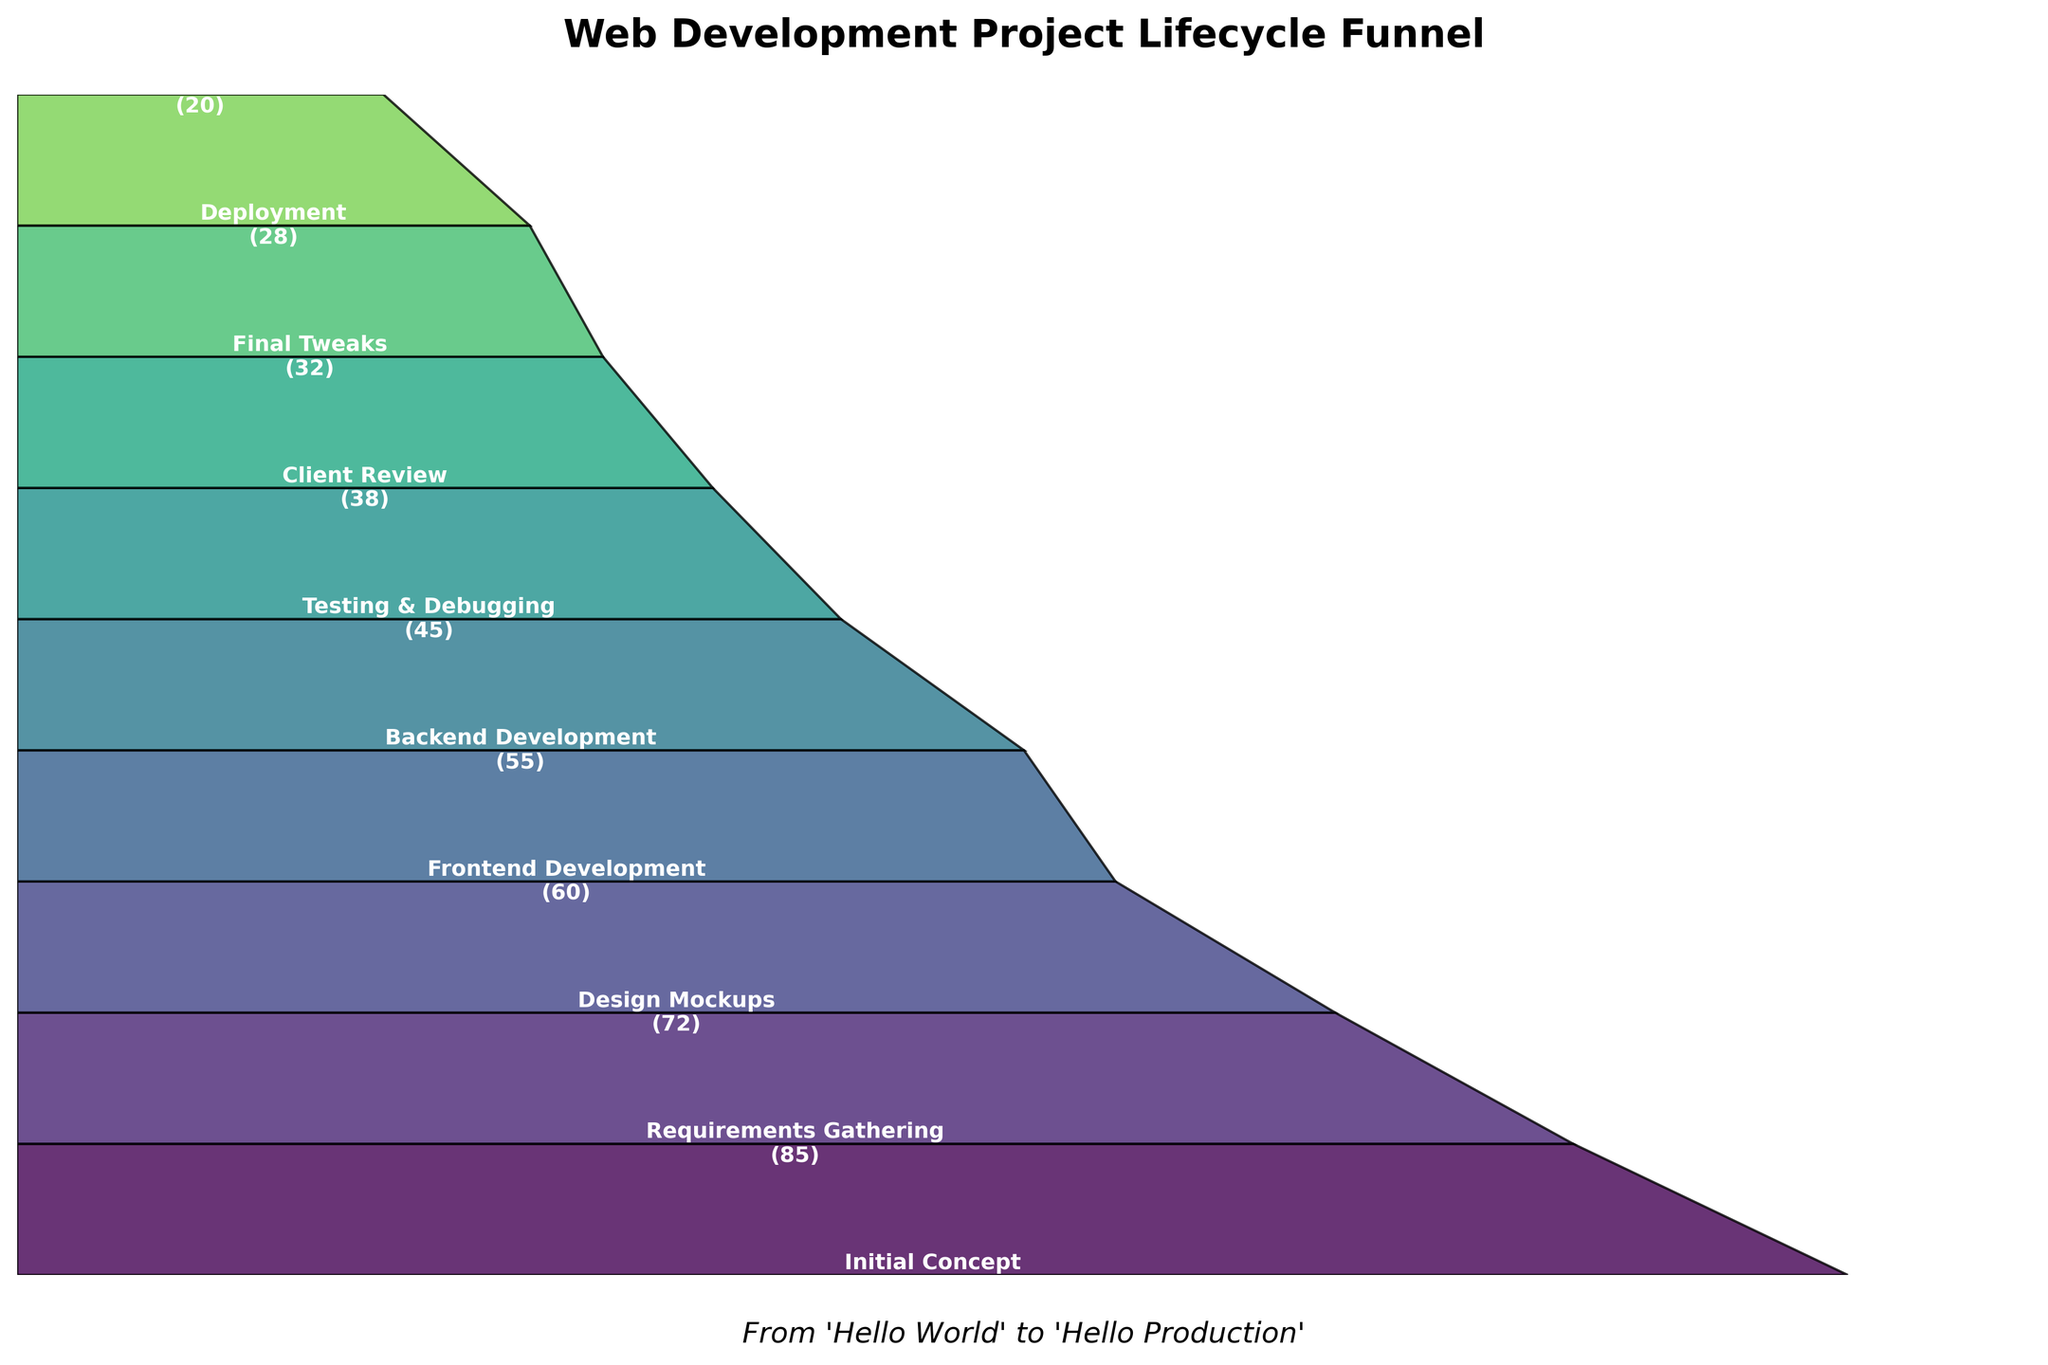What is the title of the funnel chart? The title of the funnel chart is usually located at the top of the figure. In this case, the title is "Web Development Project Lifecycle Funnel".
Answer: Web Development Project Lifecycle Funnel What stage has the lowest value? To find the stage with the lowest value, look for the value closest to zero. The stage "Post-Launch Support" has the smallest value of 20.
Answer: Post-Launch Support How many stages are represented in the funnel chart? Count the number of distinct stages listed vertically in the funnel chart. The stages are: Initial Concept, Requirements Gathering, Design Mockups, Frontend Development, Backend Development, Testing & Debugging, Client Review, Final Tweaks, Deployment, and Post-Launch Support. There are 10 stages.
Answer: 10 Which stage has the highest drop-off compared to its preceding stage? Calculate the difference between each consecutive stage's value to find the largest drop-off. The largest difference is between Initial Concept (100) and Requirements Gathering (85), which is a drop-off of 15.
Answer: Requirements Gathering What is the cumulative value from "Frontend Development" to "Post-Launch Support"? Sum the values from the stages "Frontend Development" (60), "Backend Development" (55), "Testing & Debugging" (45), "Client Review" (38), "Final Tweaks" (32), "Deployment" (28), and "Post-Launch Support" (20). Hence, 60 + 55 + 45 + 38 + 32 + 28 + 20 = 278.
Answer: 278 Which stages have a value greater than 50? Look for stages with values exceeding 50. The stages are Initial Concept (100), Requirements Gathering (85), Design Mockups (72), Frontend Development (60), and Backend Development (55).
Answer: Initial Concept, Requirements Gathering, Design Mockups, Frontend Development, Backend Development What is the difference in value between "Design Mockups" and "Client Review"? Subtract the value of "Client Review" (38) from "Design Mockups" (72). Thus, 72 - 38 = 34.
Answer: 34 How many stages have values less than the initial stage’s value? Compare each stage’s value to the initial stage's value (100). All other stages have values less than 100. There are 9 such stages.
Answer: 9 What percentage is the "Deployment" stage of the "Initial Concept" stage value? Calculate the percentage by dividing the value at "Deployment" (28) by "Initial Concept" (100) and then multiplying by 100. (28/100) * 100 = 28%.
Answer: 28 What stage is directly before "Final Tweaks"? Look at the stages in sequence and find the one that immediately precedes "Final Tweaks". "Client Review" comes before "Final Tweaks".
Answer: Client Review 